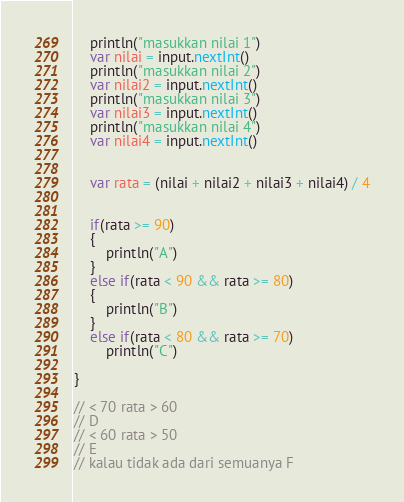<code> <loc_0><loc_0><loc_500><loc_500><_Kotlin_>    println("masukkan nilai 1")
    var nilai = input.nextInt()
    println("masukkan nilai 2")
    var nilai2 = input.nextInt()
    println("masukkan nilai 3")
    var nilai3 = input.nextInt()
    println("masukkan nilai 4")
    var nilai4 = input.nextInt()


    var rata = (nilai + nilai2 + nilai3 + nilai4) / 4


    if(rata >= 90)
    {
        println("A")
    }
    else if(rata < 90 && rata >= 80)
    {
        println("B")
    }
    else if(rata < 80 && rata >= 70)
        println("C")

}

// < 70 rata > 60
// D
// < 60 rata > 50
// E
// kalau tidak ada dari semuanya F</code> 